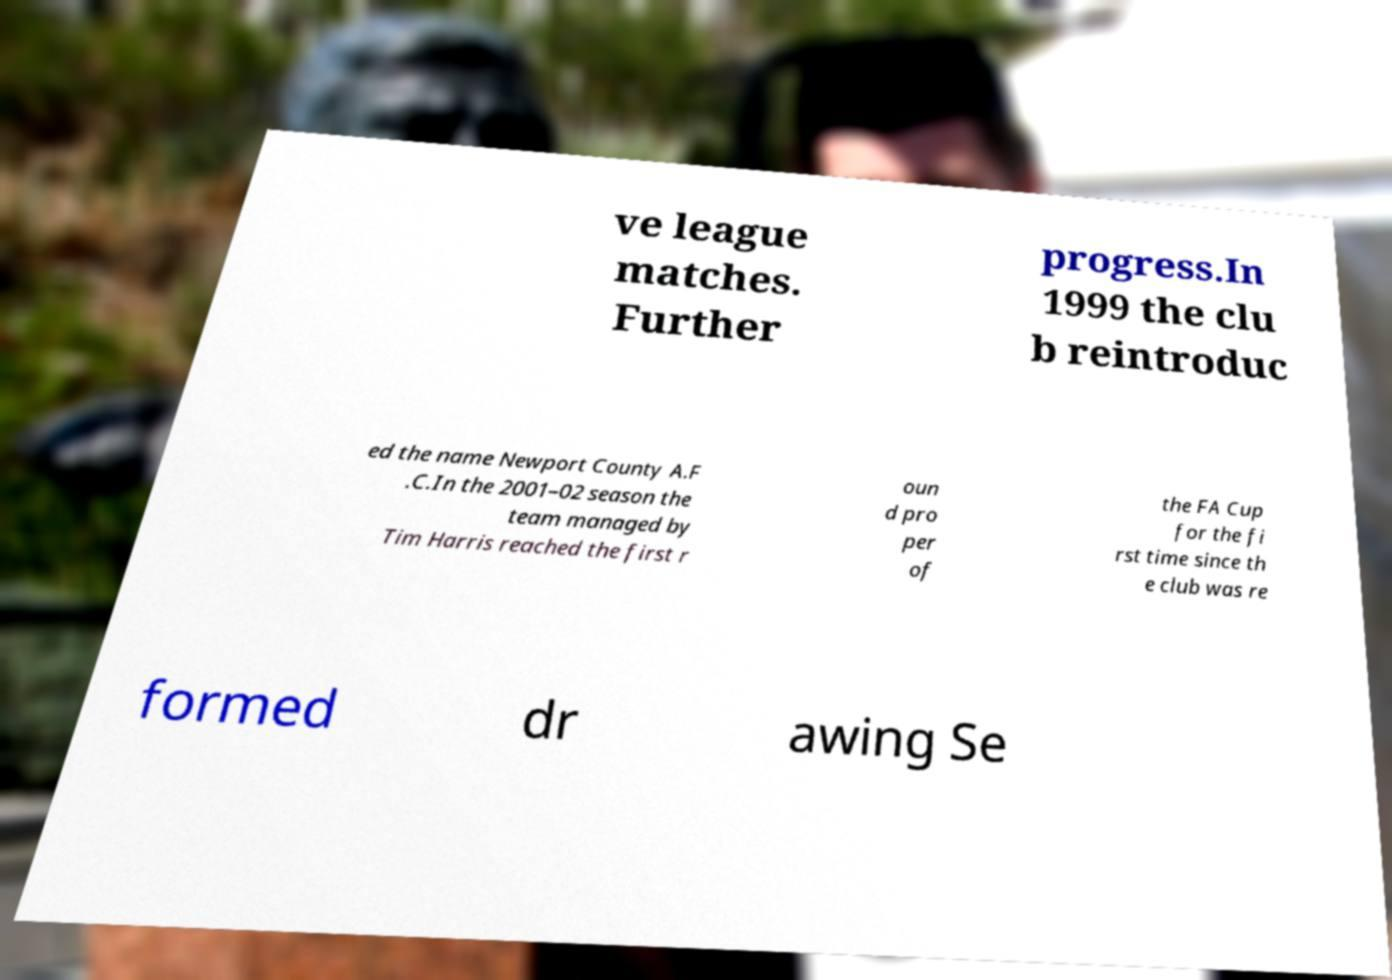Could you assist in decoding the text presented in this image and type it out clearly? ve league matches. Further progress.In 1999 the clu b reintroduc ed the name Newport County A.F .C.In the 2001–02 season the team managed by Tim Harris reached the first r oun d pro per of the FA Cup for the fi rst time since th e club was re formed dr awing Se 